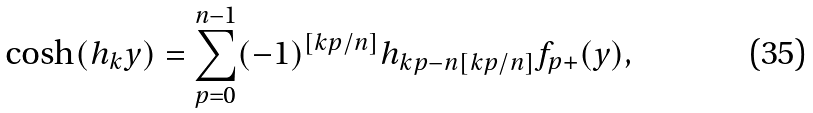Convert formula to latex. <formula><loc_0><loc_0><loc_500><loc_500>\cosh ( h _ { k } y ) = \sum _ { p = 0 } ^ { n - 1 } ( - 1 ) ^ { [ k p / n ] } h _ { k p - n [ k p / n ] } f _ { p + } ( y ) ,</formula> 